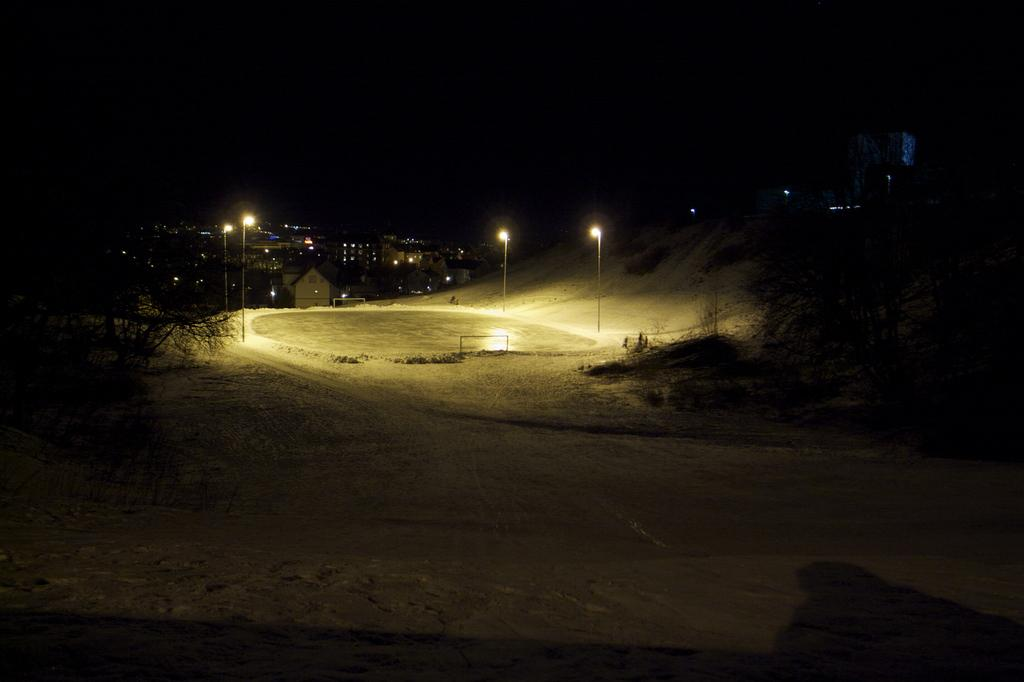What time of day is the image taken? The image is taken at night. What is visible beneath the objects and structures in the image? There is a ground visible in the image. What type of lighting is present in the image? There are street lights in the image. What can be seen in the distance in the image? There are buildings in the background of the image. What type of wound can be seen on the ground in the image? There is no wound present on the ground in the image. What sense is being utilized by the objects in the image? The objects in the image do not have senses, as they are inanimate. 